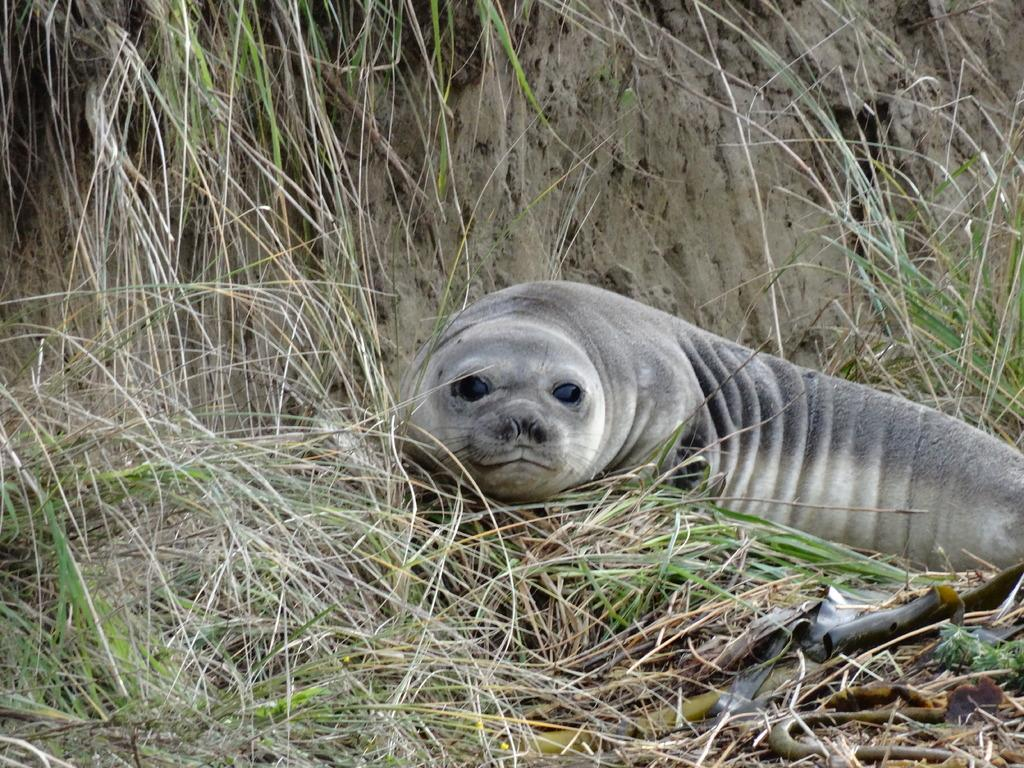What animal is present in the picture? There is a seal in the picture. What type of surface is the seal standing on? There is grass on the floor in the picture. What can be seen in the distance in the background of the picture? There is a mountain in the background of the picture. What type of terrain is visible in the picture? There is soil visible in the picture. What type of tin can be seen in the picture? There is no tin present in the picture. What day of the week is depicted in the image? The image does not depict a specific day of the week. 